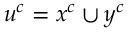Convert formula to latex. <formula><loc_0><loc_0><loc_500><loc_500>u ^ { c } = x ^ { c } \cup y ^ { c }</formula> 